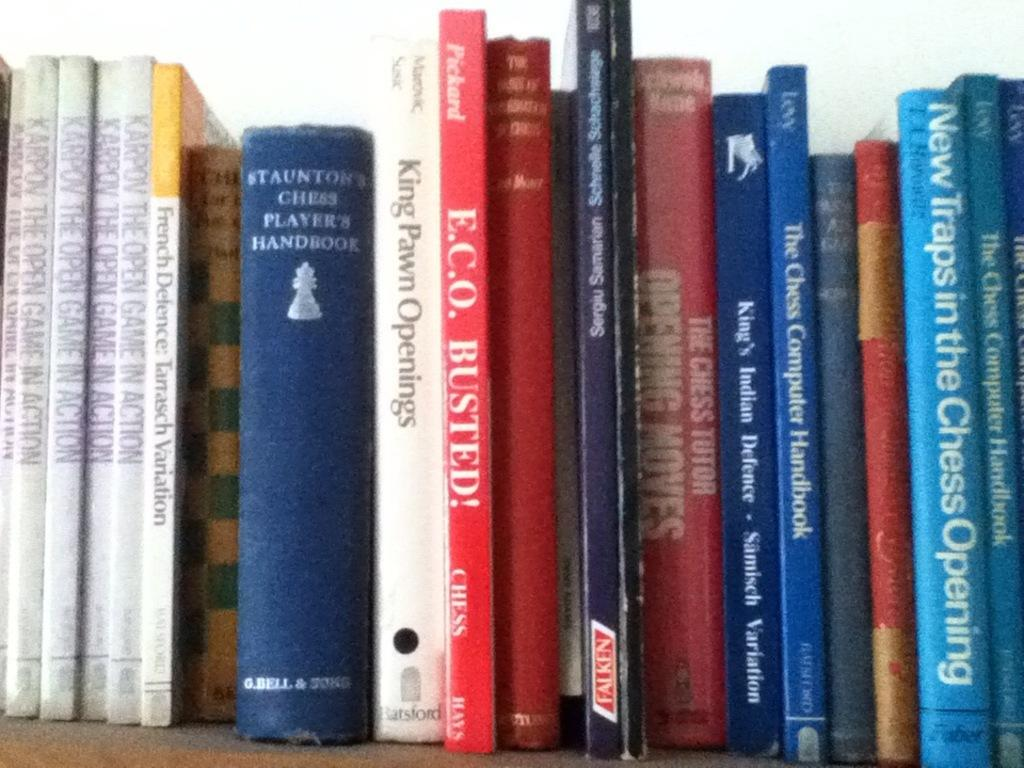<image>
Give a short and clear explanation of the subsequent image. A group of books next to each other and at least some being about chess. 